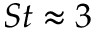Convert formula to latex. <formula><loc_0><loc_0><loc_500><loc_500>S t \approx 3</formula> 